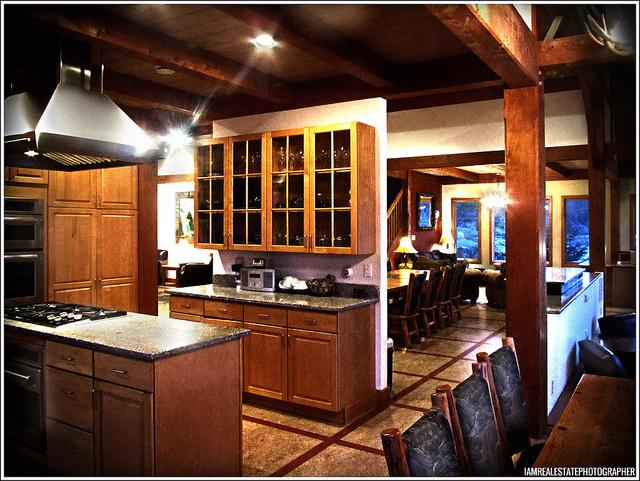Is this a restaurant?
Write a very short answer. No. Is anyone cooking?
Keep it brief. No. What object is on the bottom left?
Write a very short answer. Stove. 